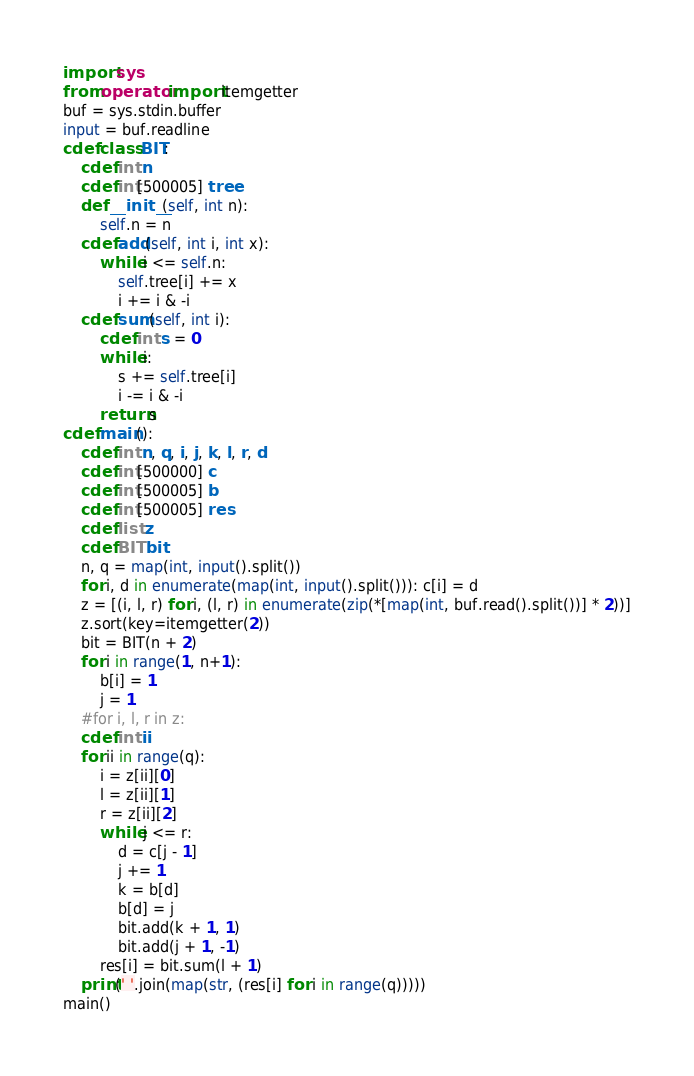Convert code to text. <code><loc_0><loc_0><loc_500><loc_500><_Cython_>import sys
from operator import itemgetter
buf = sys.stdin.buffer
input = buf.readline
cdef class BIT:
    cdef int n
    cdef int[500005] tree
    def __init__(self, int n):
        self.n = n
    cdef add(self, int i, int x):
        while i <= self.n:
            self.tree[i] += x
            i += i & -i
    cdef sum(self, int i):
        cdef int s = 0
        while i:
            s += self.tree[i]
            i -= i & -i
        return s
cdef main():
    cdef int n, q, i, j, k, l, r, d
    cdef int[500000] c
    cdef int[500005] b
    cdef int[500005] res
    cdef list z
    cdef BIT bit
    n, q = map(int, input().split())
    for i, d in enumerate(map(int, input().split())): c[i] = d
    z = [(i, l, r) for i, (l, r) in enumerate(zip(*[map(int, buf.read().split())] * 2))]
    z.sort(key=itemgetter(2))
    bit = BIT(n + 2)
    for i in range(1, n+1):
        b[i] = 1
        j = 1
    #for i, l, r in z:
    cdef int ii
    for ii in range(q):
        i = z[ii][0]
        l = z[ii][1]
        r = z[ii][2]
        while j <= r:
            d = c[j - 1]
            j += 1
            k = b[d]
            b[d] = j
            bit.add(k + 1, 1)
            bit.add(j + 1, -1)
        res[i] = bit.sum(l + 1)
    print(' '.join(map(str, (res[i] for i in range(q)))))
main()
</code> 